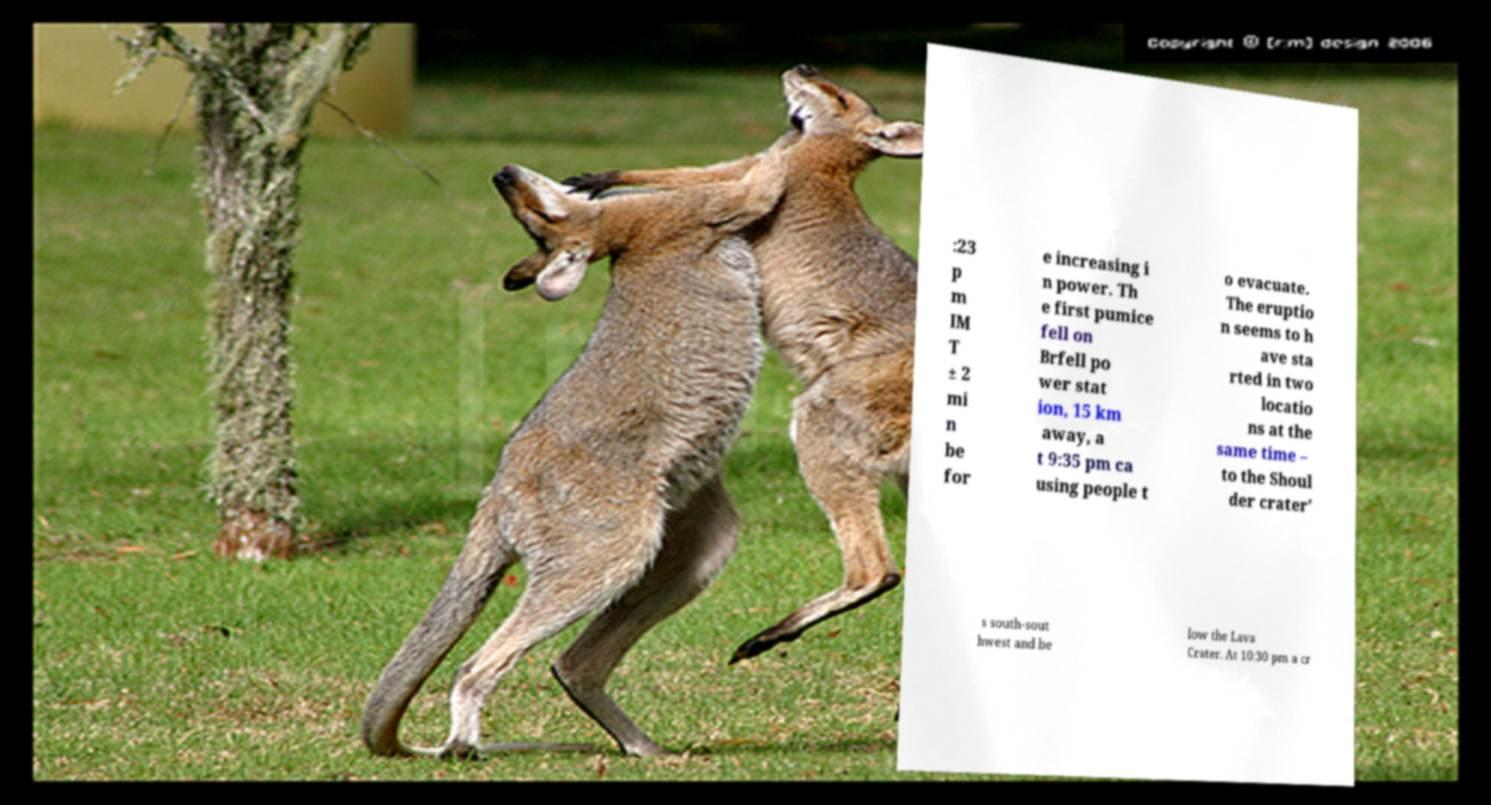There's text embedded in this image that I need extracted. Can you transcribe it verbatim? :23 p m IM T ± 2 mi n be for e increasing i n power. Th e first pumice fell on Brfell po wer stat ion, 15 km away, a t 9:35 pm ca using people t o evacuate. The eruptio n seems to h ave sta rted in two locatio ns at the same time – to the Shoul der crater' s south-sout hwest and be low the Lava Crater. At 10:30 pm a cr 